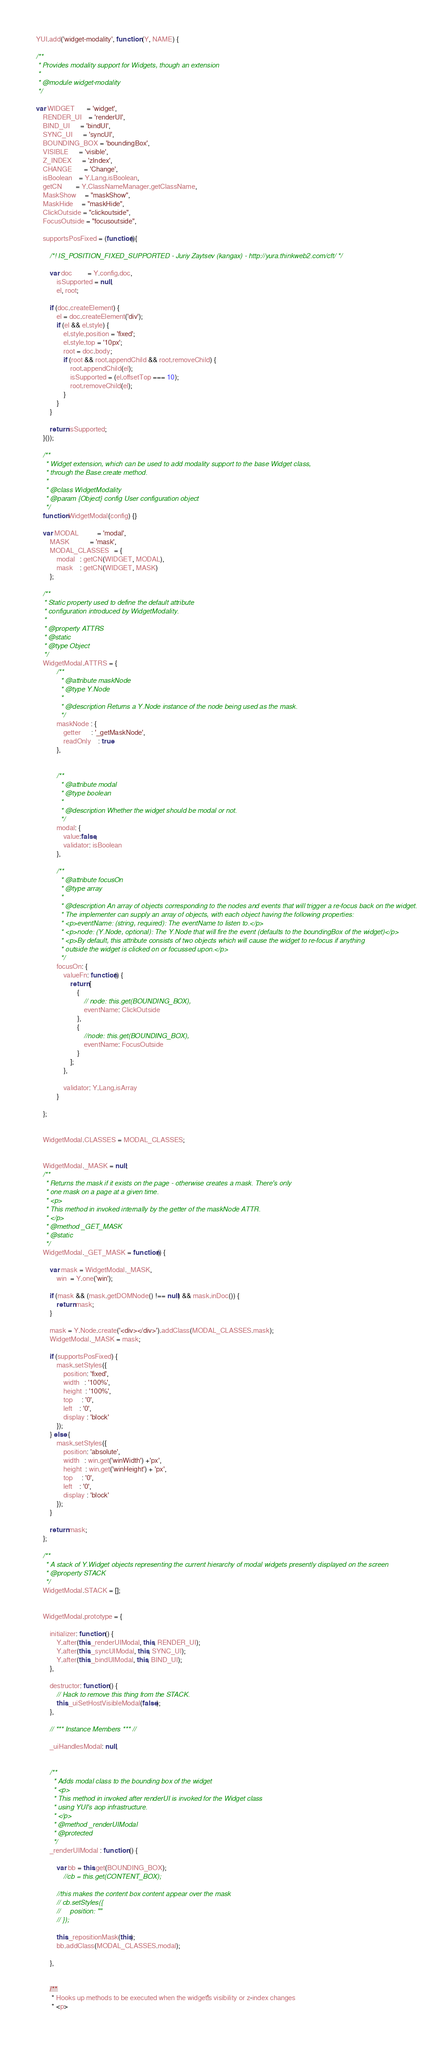Convert code to text. <code><loc_0><loc_0><loc_500><loc_500><_JavaScript_>YUI.add('widget-modality', function (Y, NAME) {

/**
 * Provides modality support for Widgets, though an extension
 *
 * @module widget-modality
 */

var WIDGET       = 'widget',
    RENDER_UI    = 'renderUI',
    BIND_UI      = 'bindUI',
    SYNC_UI      = 'syncUI',
    BOUNDING_BOX = 'boundingBox',
    VISIBLE      = 'visible',
    Z_INDEX      = 'zIndex',
    CHANGE       = 'Change',
    isBoolean    = Y.Lang.isBoolean,
    getCN        = Y.ClassNameManager.getClassName,
    MaskShow     = "maskShow",
    MaskHide     = "maskHide",
    ClickOutside = "clickoutside",
    FocusOutside = "focusoutside",

    supportsPosFixed = (function(){

        /*! IS_POSITION_FIXED_SUPPORTED - Juriy Zaytsev (kangax) - http://yura.thinkweb2.com/cft/ */

        var doc         = Y.config.doc,
            isSupported = null,
            el, root;

        if (doc.createElement) {
            el = doc.createElement('div');
            if (el && el.style) {
                el.style.position = 'fixed';
                el.style.top = '10px';
                root = doc.body;
                if (root && root.appendChild && root.removeChild) {
                    root.appendChild(el);
                    isSupported = (el.offsetTop === 10);
                    root.removeChild(el);
                }
            }
        }

        return isSupported;
    }());

    /**
     * Widget extension, which can be used to add modality support to the base Widget class,
     * through the Base.create method.
     *
     * @class WidgetModality
     * @param {Object} config User configuration object
     */
    function WidgetModal(config) {}

    var MODAL           = 'modal',
        MASK            = 'mask',
        MODAL_CLASSES   = {
            modal   : getCN(WIDGET, MODAL),
            mask    : getCN(WIDGET, MASK)
        };

    /**
    * Static property used to define the default attribute
    * configuration introduced by WidgetModality.
    *
    * @property ATTRS
    * @static
    * @type Object
    */
    WidgetModal.ATTRS = {
            /**
             * @attribute maskNode
             * @type Y.Node
             *
             * @description Returns a Y.Node instance of the node being used as the mask.
             */
            maskNode : {
                getter      : '_getMaskNode',
                readOnly    : true
            },


            /**
             * @attribute modal
             * @type boolean
             *
             * @description Whether the widget should be modal or not.
             */
            modal: {
                value:false,
                validator: isBoolean
            },

            /**
             * @attribute focusOn
             * @type array
             *
             * @description An array of objects corresponding to the nodes and events that will trigger a re-focus back on the widget.
             * The implementer can supply an array of objects, with each object having the following properties:
             * <p>eventName: (string, required): The eventName to listen to.</p>
             * <p>node: (Y.Node, optional): The Y.Node that will fire the event (defaults to the boundingBox of the widget)</p>
             * <p>By default, this attribute consists of two objects which will cause the widget to re-focus if anything
             * outside the widget is clicked on or focussed upon.</p>
             */
            focusOn: {
                valueFn: function() {
                    return [
                        {
                            // node: this.get(BOUNDING_BOX),
                            eventName: ClickOutside
                        },
                        {
                            //node: this.get(BOUNDING_BOX),
                            eventName: FocusOutside
                        }
                    ];
                },

                validator: Y.Lang.isArray
            }

    };


    WidgetModal.CLASSES = MODAL_CLASSES;


    WidgetModal._MASK = null;
    /**
     * Returns the mask if it exists on the page - otherwise creates a mask. There's only
     * one mask on a page at a given time.
     * <p>
     * This method in invoked internally by the getter of the maskNode ATTR.
     * </p>
     * @method _GET_MASK
     * @static
     */
    WidgetModal._GET_MASK = function() {

        var mask = WidgetModal._MASK,
            win  = Y.one('win');

        if (mask && (mask.getDOMNode() !== null) && mask.inDoc()) {
            return mask;
        }

        mask = Y.Node.create('<div></div>').addClass(MODAL_CLASSES.mask);
        WidgetModal._MASK = mask;

        if (supportsPosFixed) {
            mask.setStyles({
                position: 'fixed',
                width   : '100%',
                height  : '100%',
                top     : '0',
                left    : '0',
                display : 'block'
            });
        } else {
            mask.setStyles({
                position: 'absolute',
                width   : win.get('winWidth') +'px',
                height  : win.get('winHeight') + 'px',
                top     : '0',
                left    : '0',
                display : 'block'
            });
        }

        return mask;
    };

    /**
     * A stack of Y.Widget objects representing the current hierarchy of modal widgets presently displayed on the screen
     * @property STACK
     */
    WidgetModal.STACK = [];


    WidgetModal.prototype = {

        initializer: function () {
            Y.after(this._renderUIModal, this, RENDER_UI);
            Y.after(this._syncUIModal, this, SYNC_UI);
            Y.after(this._bindUIModal, this, BIND_UI);
        },

        destructor: function () {
            // Hack to remove this thing from the STACK.
            this._uiSetHostVisibleModal(false);
        },

        // *** Instance Members *** //

        _uiHandlesModal: null,


        /**
         * Adds modal class to the bounding box of the widget
         * <p>
         * This method in invoked after renderUI is invoked for the Widget class
         * using YUI's aop infrastructure.
         * </p>
         * @method _renderUIModal
         * @protected
         */
        _renderUIModal : function () {

            var bb = this.get(BOUNDING_BOX);
                //cb = this.get(CONTENT_BOX);

            //this makes the content box content appear over the mask
            // cb.setStyles({
            //     position: ""
            // });

            this._repositionMask(this);
            bb.addClass(MODAL_CLASSES.modal);

        },


        /**
         * Hooks up methods to be executed when the widget's visibility or z-index changes
         * <p></code> 